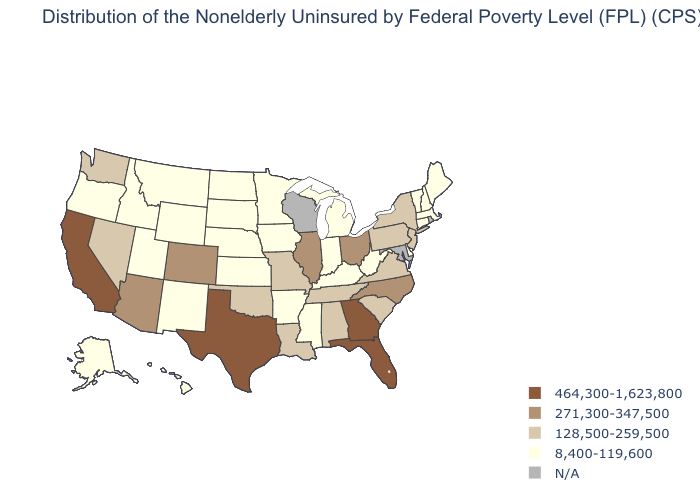Does Florida have the highest value in the South?
Be succinct. Yes. Name the states that have a value in the range 8,400-119,600?
Short answer required. Alaska, Arkansas, Connecticut, Delaware, Hawaii, Idaho, Indiana, Iowa, Kansas, Kentucky, Maine, Massachusetts, Michigan, Minnesota, Mississippi, Montana, Nebraska, New Hampshire, New Mexico, North Dakota, Oregon, South Dakota, Utah, Vermont, West Virginia, Wyoming. What is the lowest value in states that border New Hampshire?
Give a very brief answer. 8,400-119,600. Name the states that have a value in the range 464,300-1,623,800?
Concise answer only. California, Florida, Georgia, Texas. Is the legend a continuous bar?
Give a very brief answer. No. Name the states that have a value in the range 464,300-1,623,800?
Concise answer only. California, Florida, Georgia, Texas. Name the states that have a value in the range 128,500-259,500?
Be succinct. Alabama, Louisiana, Missouri, Nevada, New Jersey, New York, Oklahoma, Pennsylvania, South Carolina, Tennessee, Virginia, Washington. What is the highest value in the USA?
Be succinct. 464,300-1,623,800. Which states have the highest value in the USA?
Quick response, please. California, Florida, Georgia, Texas. What is the highest value in states that border New York?
Concise answer only. 128,500-259,500. Does New York have the highest value in the Northeast?
Keep it brief. Yes. Name the states that have a value in the range 128,500-259,500?
Concise answer only. Alabama, Louisiana, Missouri, Nevada, New Jersey, New York, Oklahoma, Pennsylvania, South Carolina, Tennessee, Virginia, Washington. What is the value of Michigan?
Be succinct. 8,400-119,600. 